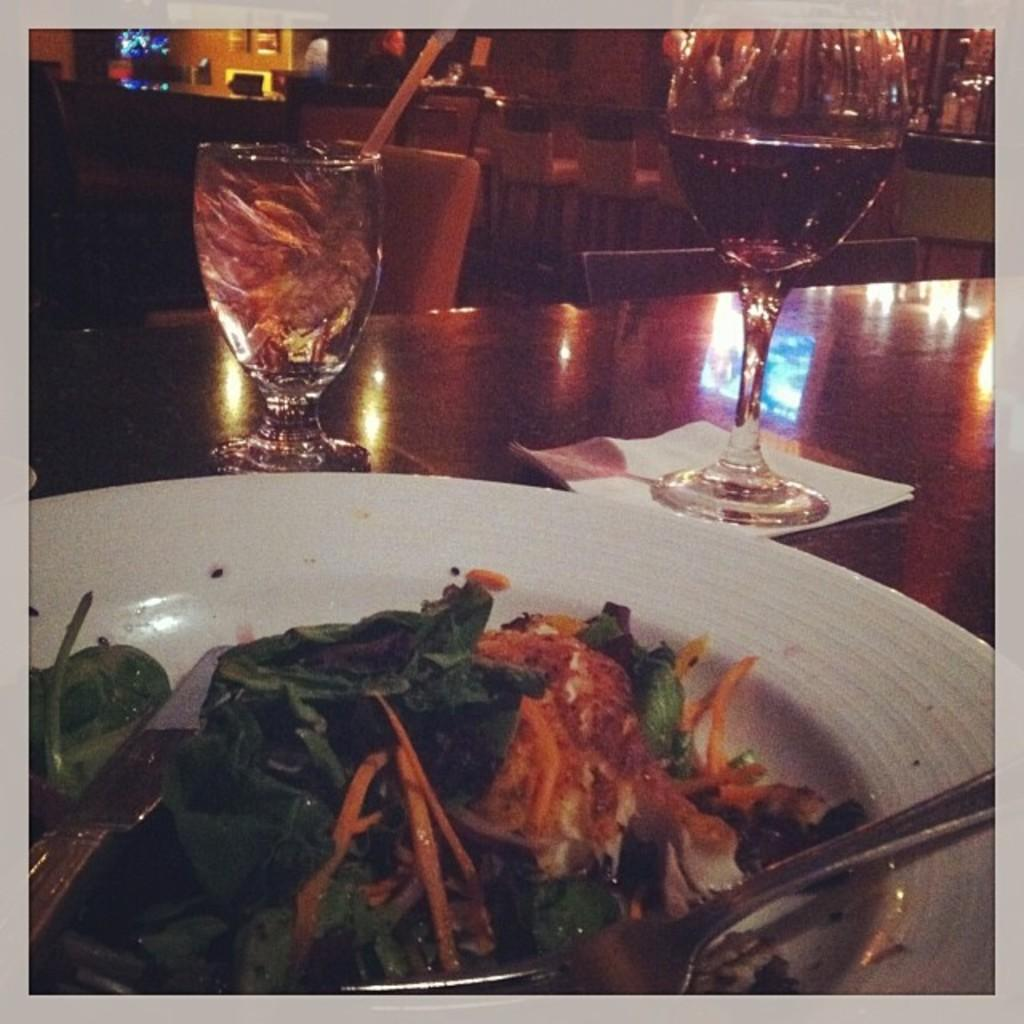What is on the plate in the image? There is food in a plate in the image. What can be seen on the table in the image? There are two glasses on a table in the image. What is visible in the background of the image? There is a wall visible in the background of the image. Is the food in the plate made of yarn in the image? No, the food in the plate is not made of yarn; it is a regular meal. Can you see any quicksand in the image? No, there is no quicksand present in the image. 